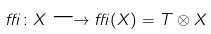Convert formula to latex. <formula><loc_0><loc_0><loc_500><loc_500>\delta \colon X \longrightarrow \delta ( X ) = T \otimes X</formula> 